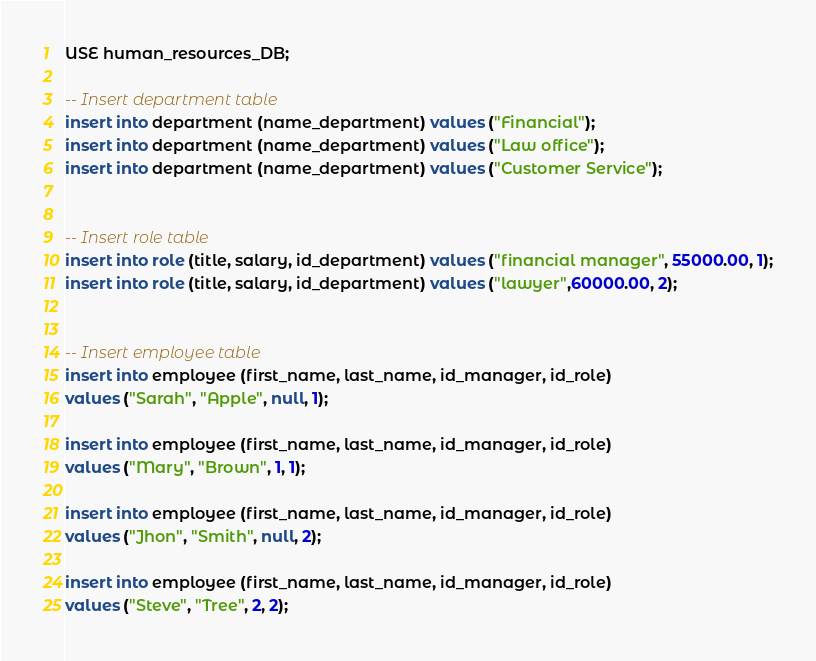Convert code to text. <code><loc_0><loc_0><loc_500><loc_500><_SQL_>
USE human_resources_DB;

-- Insert department table
insert into department (name_department) values ("Financial");
insert into department (name_department) values ("Law office");
insert into department (name_department) values ("Customer Service");


-- Insert role table
insert into role (title, salary, id_department) values ("financial manager", 55000.00, 1);
insert into role (title, salary, id_department) values ("lawyer",60000.00, 2);


-- Insert employee table
insert into employee (first_name, last_name, id_manager, id_role)
values ("Sarah", "Apple", null, 1);

insert into employee (first_name, last_name, id_manager, id_role)
values ("Mary", "Brown", 1, 1);

insert into employee (first_name, last_name, id_manager, id_role)
values ("Jhon", "Smith", null, 2);

insert into employee (first_name, last_name, id_manager, id_role)
values ("Steve", "Tree", 2, 2);</code> 